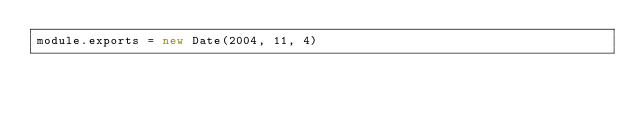Convert code to text. <code><loc_0><loc_0><loc_500><loc_500><_JavaScript_>module.exports = new Date(2004, 11, 4)
</code> 